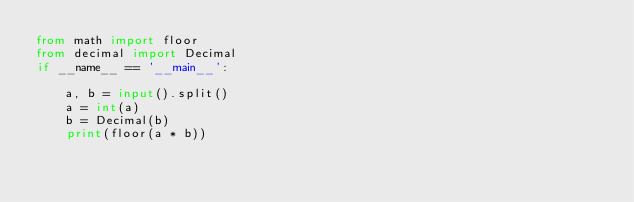Convert code to text. <code><loc_0><loc_0><loc_500><loc_500><_Python_>from math import floor
from decimal import Decimal
if __name__ == '__main__':

    a, b = input().split()
    a = int(a)
    b = Decimal(b)
    print(floor(a * b))</code> 